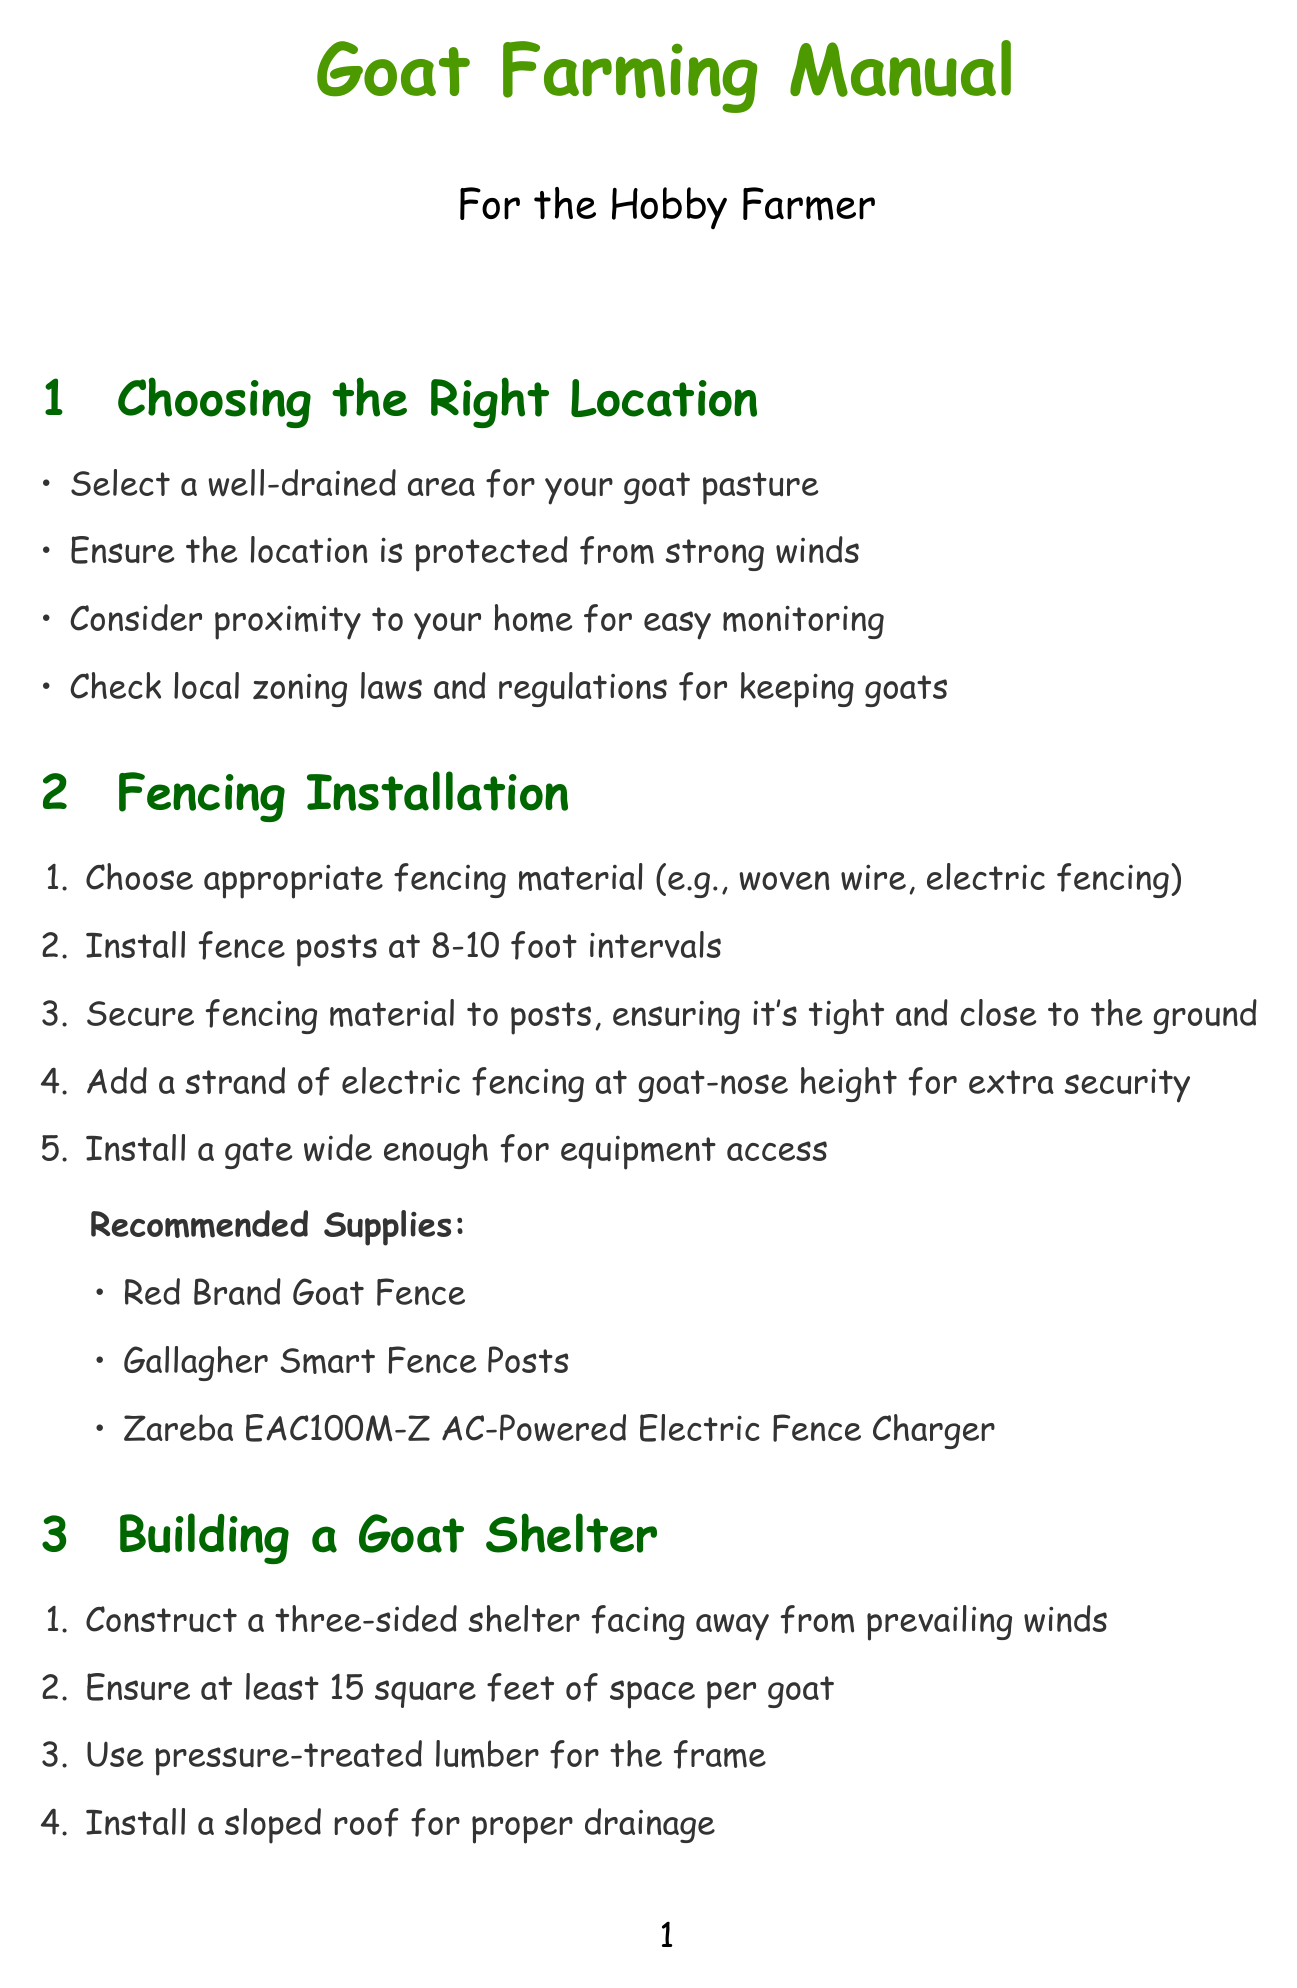What is the minimum shelter size for goats? The document states that the minimum shelter size is 15 square feet per goat.
Answer: 15 square feet What is the recommended fencing height for Nigerian Dwarf goats? The specifications for Nigerian Dwarf goats indicate a fencing height of 4 feet.
Answer: 4 feet What type of fencing material is suggested? The document recommends fencing material such as woven wire or electric fencing.
Answer: woven wire, electric fencing How many items are listed under Additional Equipment? There are three items listed under Additional Equipment in the document.
Answer: three What is a recommended product for a hay feeder? A specific recommended product mentioned for a hay feeder is the Behlen Country 51110048 Galvanized Steel Round Bale Hay Feeder.
Answer: Behlen Country 51110048 Galvanized Steel Round Bale Hay Feeder How should the pasture be managed according to the document? The document suggests dividing the pasture into rotating sections to prevent overgrazing.
Answer: rotating sections What is one included item in the kidding kit? The document lists several essential items for the kidding kit, one of which is Iodine solution.
Answer: Iodine solution What is the shelter size needed per goat for Nubian goats? The document specifies that Nubian goats require 20 square feet of shelter space per goat.
Answer: 20 square feet 